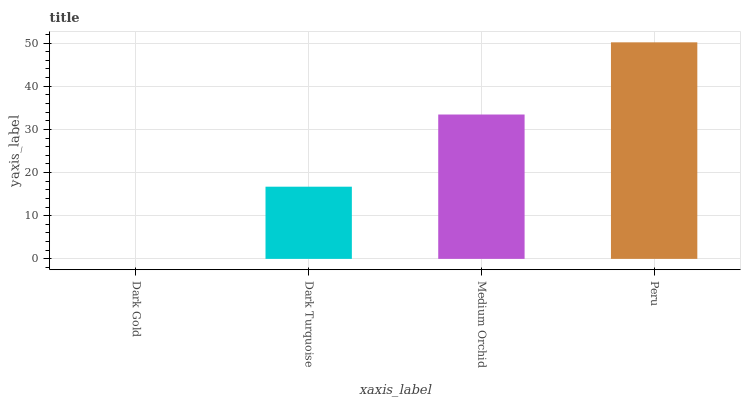Is Dark Gold the minimum?
Answer yes or no. Yes. Is Peru the maximum?
Answer yes or no. Yes. Is Dark Turquoise the minimum?
Answer yes or no. No. Is Dark Turquoise the maximum?
Answer yes or no. No. Is Dark Turquoise greater than Dark Gold?
Answer yes or no. Yes. Is Dark Gold less than Dark Turquoise?
Answer yes or no. Yes. Is Dark Gold greater than Dark Turquoise?
Answer yes or no. No. Is Dark Turquoise less than Dark Gold?
Answer yes or no. No. Is Medium Orchid the high median?
Answer yes or no. Yes. Is Dark Turquoise the low median?
Answer yes or no. Yes. Is Dark Turquoise the high median?
Answer yes or no. No. Is Medium Orchid the low median?
Answer yes or no. No. 